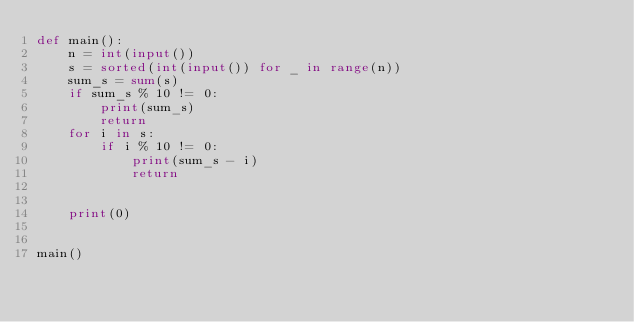<code> <loc_0><loc_0><loc_500><loc_500><_Python_>def main():
    n = int(input())
    s = sorted(int(input()) for _ in range(n))
    sum_s = sum(s)
    if sum_s % 10 != 0:
        print(sum_s)
        return
    for i in s:
        if i % 10 != 0:
            print(sum_s - i)
            return


    print(0)


main()</code> 